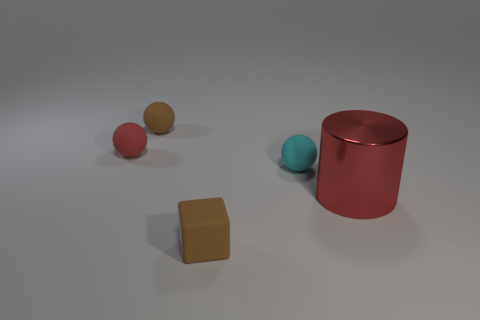There is a thing that is behind the metal object and to the right of the brown block; what is its color?
Offer a terse response. Cyan. What number of small red spheres are there?
Your answer should be very brief. 1. Is there anything else that is the same size as the red metallic cylinder?
Offer a terse response. No. Is the large red thing made of the same material as the block?
Provide a succinct answer. No. There is a brown thing that is in front of the big red cylinder; is its size the same as the red thing on the right side of the cube?
Make the answer very short. No. Is the number of things less than the number of large yellow rubber objects?
Your answer should be very brief. No. What number of shiny objects are either big red objects or brown cubes?
Make the answer very short. 1. Is there a ball in front of the tiny sphere that is left of the brown ball?
Your response must be concise. Yes. Do the ball right of the brown ball and the red ball have the same material?
Offer a terse response. Yes. How many other objects are there of the same color as the matte block?
Make the answer very short. 1. 